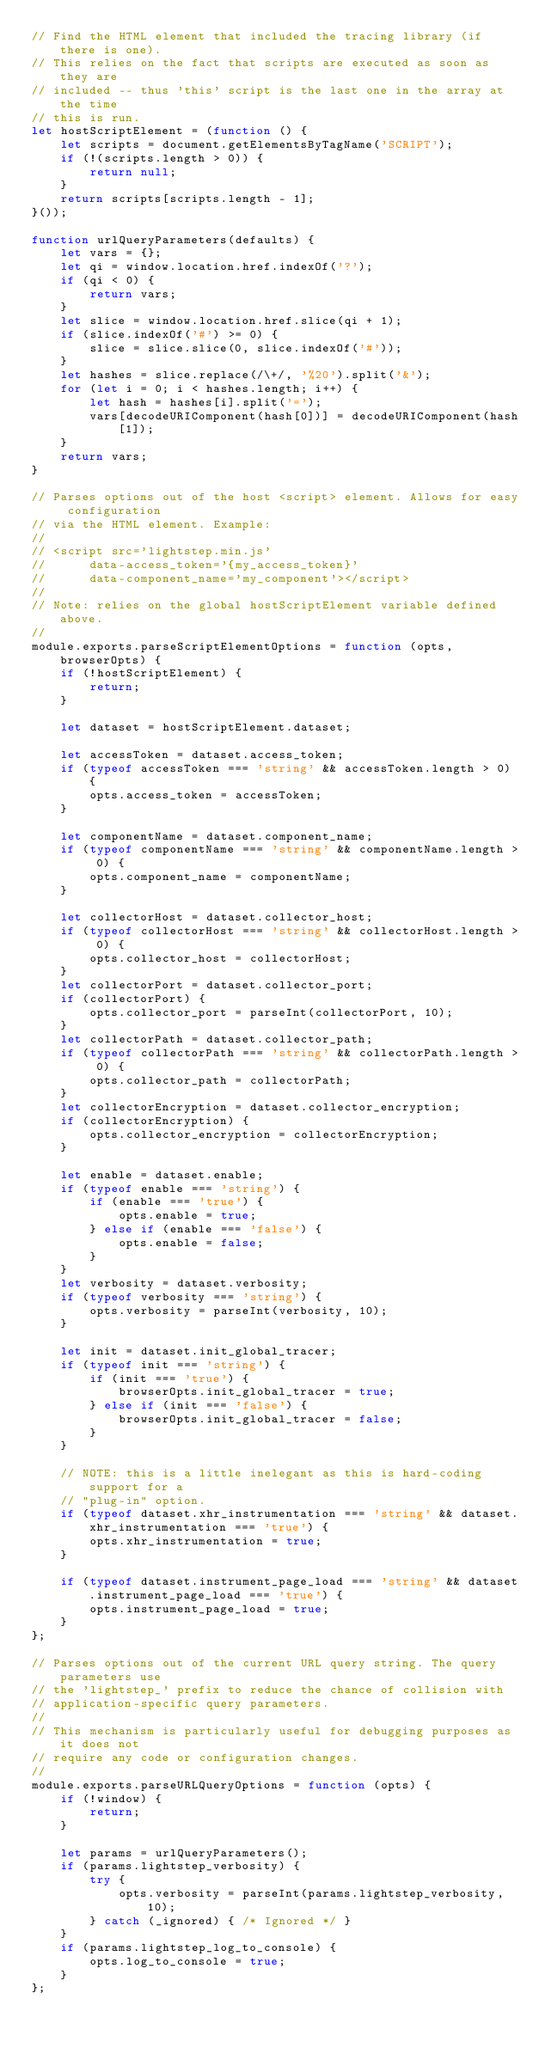<code> <loc_0><loc_0><loc_500><loc_500><_JavaScript_>// Find the HTML element that included the tracing library (if there is one).
// This relies on the fact that scripts are executed as soon as they are
// included -- thus 'this' script is the last one in the array at the time
// this is run.
let hostScriptElement = (function () {
    let scripts = document.getElementsByTagName('SCRIPT');
    if (!(scripts.length > 0)) {
        return null;
    }
    return scripts[scripts.length - 1];
}());

function urlQueryParameters(defaults) {
    let vars = {};
    let qi = window.location.href.indexOf('?');
    if (qi < 0) {
        return vars;
    }
    let slice = window.location.href.slice(qi + 1);
    if (slice.indexOf('#') >= 0) {
        slice = slice.slice(0, slice.indexOf('#'));
    }
    let hashes = slice.replace(/\+/, '%20').split('&');
    for (let i = 0; i < hashes.length; i++) {
        let hash = hashes[i].split('=');
        vars[decodeURIComponent(hash[0])] = decodeURIComponent(hash[1]);
    }
    return vars;
}

// Parses options out of the host <script> element. Allows for easy configuration
// via the HTML element. Example:
//
// <script src='lightstep.min.js'
//      data-access_token='{my_access_token}'
//      data-component_name='my_component'></script>
//
// Note: relies on the global hostScriptElement variable defined above.
//
module.exports.parseScriptElementOptions = function (opts, browserOpts) {
    if (!hostScriptElement) {
        return;
    }

    let dataset = hostScriptElement.dataset;

    let accessToken = dataset.access_token;
    if (typeof accessToken === 'string' && accessToken.length > 0) {
        opts.access_token = accessToken;
    }

    let componentName = dataset.component_name;
    if (typeof componentName === 'string' && componentName.length > 0) {
        opts.component_name = componentName;
    }

    let collectorHost = dataset.collector_host;
    if (typeof collectorHost === 'string' && collectorHost.length > 0) {
        opts.collector_host = collectorHost;
    }
    let collectorPort = dataset.collector_port;
    if (collectorPort) {
        opts.collector_port = parseInt(collectorPort, 10);
    }
    let collectorPath = dataset.collector_path;
    if (typeof collectorPath === 'string' && collectorPath.length > 0) {
        opts.collector_path = collectorPath;
    }
    let collectorEncryption = dataset.collector_encryption;
    if (collectorEncryption) {
        opts.collector_encryption = collectorEncryption;
    }

    let enable = dataset.enable;
    if (typeof enable === 'string') {
        if (enable === 'true') {
            opts.enable = true;
        } else if (enable === 'false') {
            opts.enable = false;
        }
    }
    let verbosity = dataset.verbosity;
    if (typeof verbosity === 'string') {
        opts.verbosity = parseInt(verbosity, 10);
    }

    let init = dataset.init_global_tracer;
    if (typeof init === 'string') {
        if (init === 'true') {
            browserOpts.init_global_tracer = true;
        } else if (init === 'false') {
            browserOpts.init_global_tracer = false;
        }
    }

    // NOTE: this is a little inelegant as this is hard-coding support for a
    // "plug-in" option.
    if (typeof dataset.xhr_instrumentation === 'string' && dataset.xhr_instrumentation === 'true') {
        opts.xhr_instrumentation = true;
    }

    if (typeof dataset.instrument_page_load === 'string' && dataset.instrument_page_load === 'true') {
        opts.instrument_page_load = true;
    }
};

// Parses options out of the current URL query string. The query parameters use
// the 'lightstep_' prefix to reduce the chance of collision with
// application-specific query parameters.
//
// This mechanism is particularly useful for debugging purposes as it does not
// require any code or configuration changes.
//
module.exports.parseURLQueryOptions = function (opts) {
    if (!window) {
        return;
    }

    let params = urlQueryParameters();
    if (params.lightstep_verbosity) {
        try {
            opts.verbosity = parseInt(params.lightstep_verbosity, 10);
        } catch (_ignored) { /* Ignored */ }
    }
    if (params.lightstep_log_to_console) {
        opts.log_to_console = true;
    }
};
</code> 